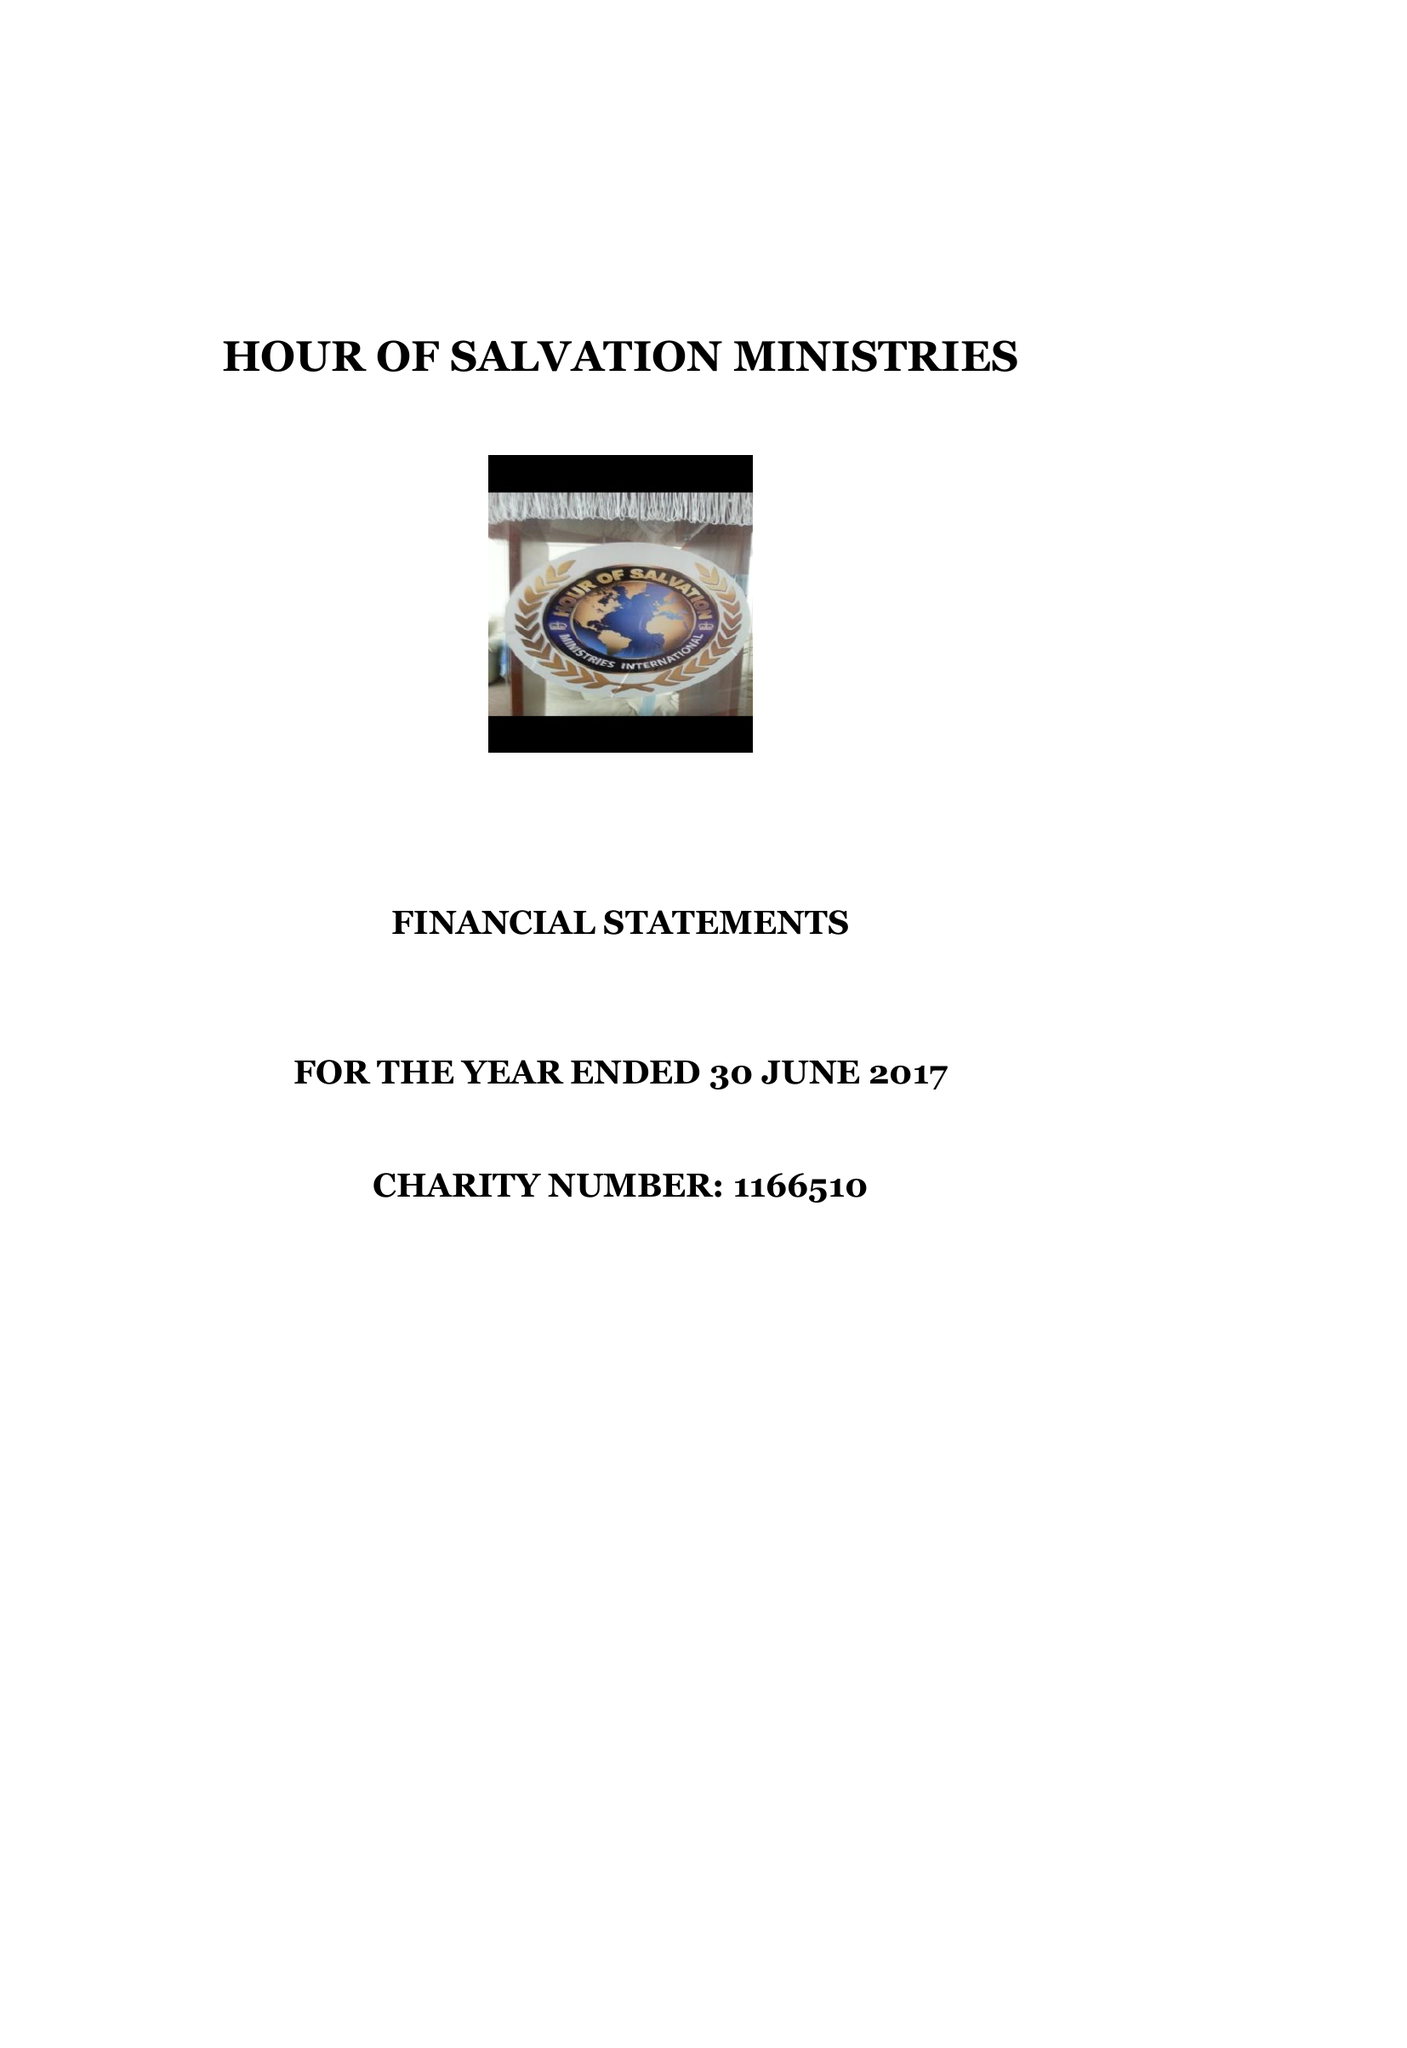What is the value for the income_annually_in_british_pounds?
Answer the question using a single word or phrase. 12840.00 